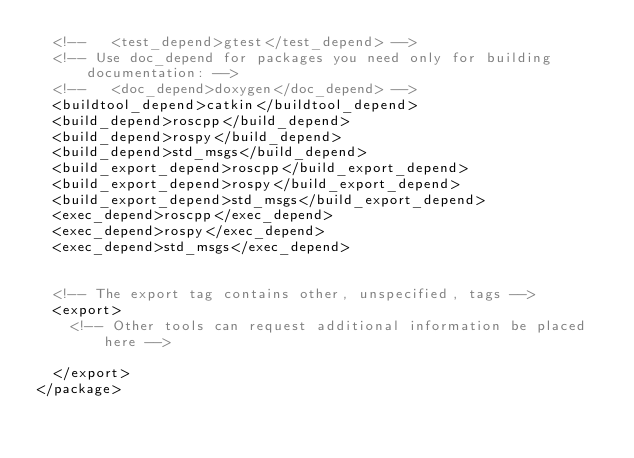<code> <loc_0><loc_0><loc_500><loc_500><_XML_>  <!--   <test_depend>gtest</test_depend> -->
  <!-- Use doc_depend for packages you need only for building documentation: -->
  <!--   <doc_depend>doxygen</doc_depend> -->
  <buildtool_depend>catkin</buildtool_depend>
  <build_depend>roscpp</build_depend>
  <build_depend>rospy</build_depend>
  <build_depend>std_msgs</build_depend>
  <build_export_depend>roscpp</build_export_depend>
  <build_export_depend>rospy</build_export_depend>
  <build_export_depend>std_msgs</build_export_depend>
  <exec_depend>roscpp</exec_depend>
  <exec_depend>rospy</exec_depend>
  <exec_depend>std_msgs</exec_depend>


  <!-- The export tag contains other, unspecified, tags -->
  <export>
    <!-- Other tools can request additional information be placed here -->

  </export>
</package>
</code> 